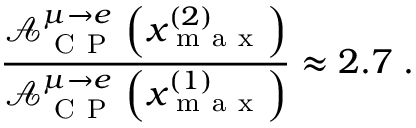Convert formula to latex. <formula><loc_0><loc_0><loc_500><loc_500>\frac { \mathcal { A } _ { C P } ^ { \mu \rightarrow e } \left ( x _ { m a x } ^ { ( 2 ) } \right ) } { \mathcal { A } _ { C P } ^ { \mu \rightarrow e } \left ( x _ { m a x } ^ { ( 1 ) } \right ) } \approx 2 . 7 \, .</formula> 